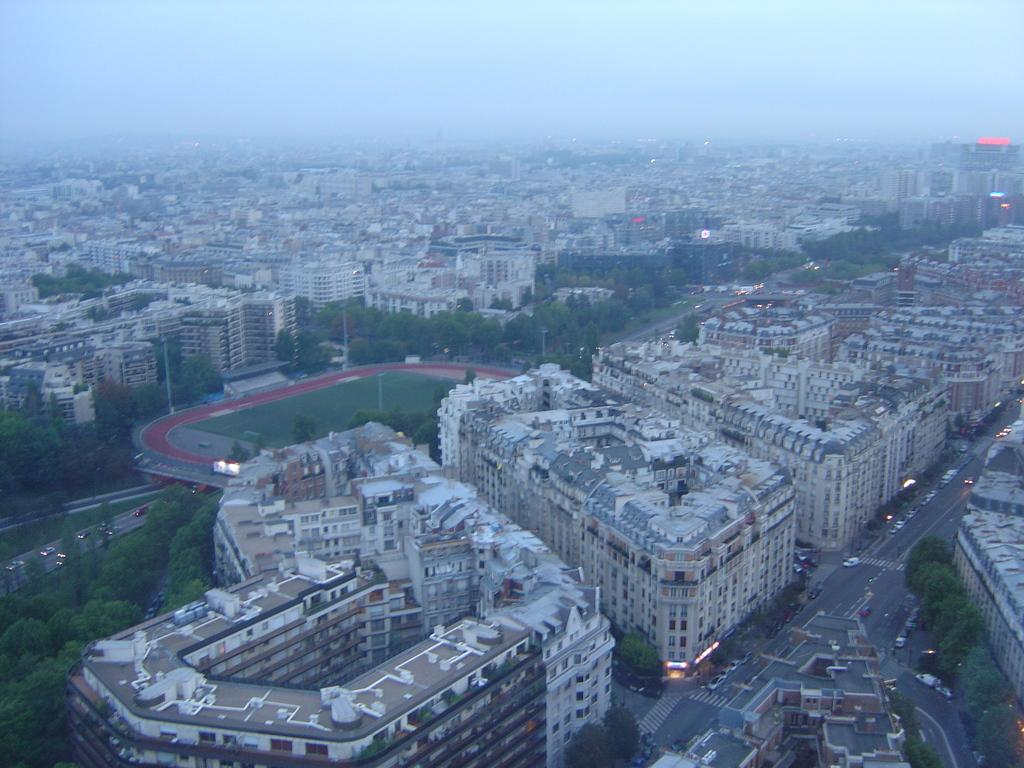What type of structures can be seen in the image? There are many buildings in the image. What else can be seen on the ground in the image? There is a road with vehicles and trees in the image. What are the poles used for in the image? The poles are likely used for supporting wires or signs in the image. What type of surface is visible on the ground? The ground has grass in the image. What is visible at the top of the image? The sky is visible at the top of the image. What type of silk is draped over the street in the image? There is no silk present in the image; it features buildings, a road with vehicles, poles, trees, grass, and the sky. How many rooms can be seen in the image? There are no rooms visible in the image, as it is an outdoor scene with buildings, a road, poles, trees, grass, and the sky. 